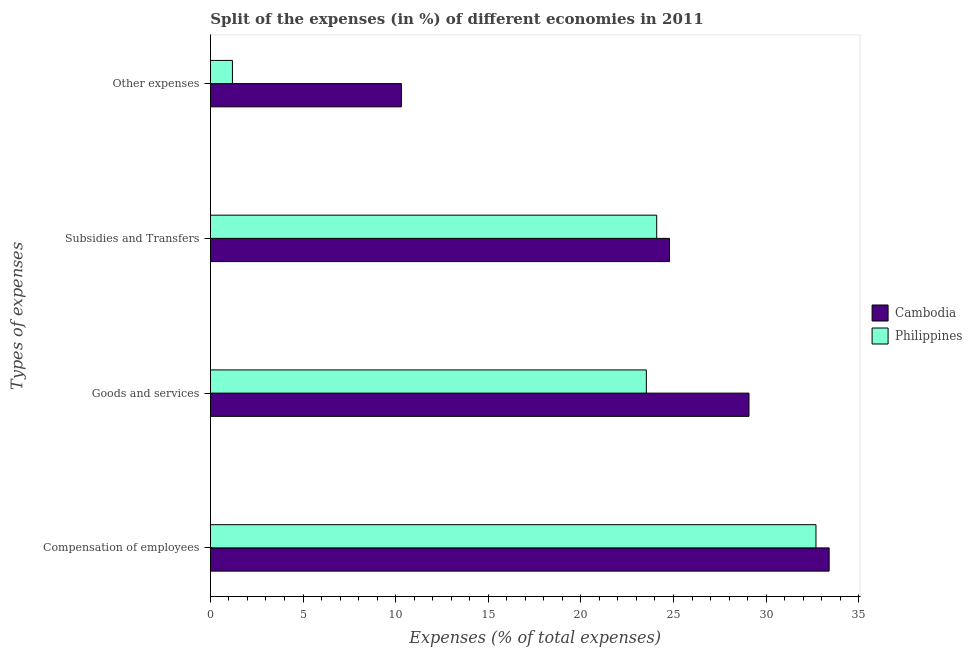How many different coloured bars are there?
Make the answer very short. 2. How many bars are there on the 2nd tick from the top?
Your answer should be compact. 2. What is the label of the 4th group of bars from the top?
Give a very brief answer. Compensation of employees. What is the percentage of amount spent on compensation of employees in Philippines?
Offer a terse response. 32.69. Across all countries, what is the maximum percentage of amount spent on compensation of employees?
Give a very brief answer. 33.4. Across all countries, what is the minimum percentage of amount spent on subsidies?
Make the answer very short. 24.09. In which country was the percentage of amount spent on other expenses maximum?
Offer a terse response. Cambodia. What is the total percentage of amount spent on goods and services in the graph?
Your answer should be very brief. 52.61. What is the difference between the percentage of amount spent on subsidies in Cambodia and that in Philippines?
Your response must be concise. 0.69. What is the difference between the percentage of amount spent on subsidies in Philippines and the percentage of amount spent on compensation of employees in Cambodia?
Your response must be concise. -9.31. What is the average percentage of amount spent on subsidies per country?
Your answer should be very brief. 24.44. What is the difference between the percentage of amount spent on goods and services and percentage of amount spent on other expenses in Cambodia?
Offer a terse response. 18.76. In how many countries, is the percentage of amount spent on compensation of employees greater than 27 %?
Offer a terse response. 2. What is the ratio of the percentage of amount spent on goods and services in Philippines to that in Cambodia?
Provide a short and direct response. 0.81. Is the difference between the percentage of amount spent on other expenses in Cambodia and Philippines greater than the difference between the percentage of amount spent on compensation of employees in Cambodia and Philippines?
Offer a terse response. Yes. What is the difference between the highest and the second highest percentage of amount spent on compensation of employees?
Keep it short and to the point. 0.71. What is the difference between the highest and the lowest percentage of amount spent on other expenses?
Keep it short and to the point. 9.12. In how many countries, is the percentage of amount spent on goods and services greater than the average percentage of amount spent on goods and services taken over all countries?
Keep it short and to the point. 1. Is the sum of the percentage of amount spent on compensation of employees in Cambodia and Philippines greater than the maximum percentage of amount spent on goods and services across all countries?
Provide a succinct answer. Yes. Is it the case that in every country, the sum of the percentage of amount spent on goods and services and percentage of amount spent on compensation of employees is greater than the sum of percentage of amount spent on subsidies and percentage of amount spent on other expenses?
Offer a terse response. No. What does the 2nd bar from the top in Goods and services represents?
Keep it short and to the point. Cambodia. What does the 1st bar from the bottom in Subsidies and Transfers represents?
Provide a short and direct response. Cambodia. Are all the bars in the graph horizontal?
Your answer should be compact. Yes. How many countries are there in the graph?
Make the answer very short. 2. Does the graph contain any zero values?
Your answer should be compact. No. Where does the legend appear in the graph?
Offer a terse response. Center right. How many legend labels are there?
Make the answer very short. 2. What is the title of the graph?
Offer a terse response. Split of the expenses (in %) of different economies in 2011. Does "Vanuatu" appear as one of the legend labels in the graph?
Offer a terse response. No. What is the label or title of the X-axis?
Ensure brevity in your answer.  Expenses (% of total expenses). What is the label or title of the Y-axis?
Provide a succinct answer. Types of expenses. What is the Expenses (% of total expenses) of Cambodia in Compensation of employees?
Ensure brevity in your answer.  33.4. What is the Expenses (% of total expenses) of Philippines in Compensation of employees?
Your answer should be compact. 32.69. What is the Expenses (% of total expenses) of Cambodia in Goods and services?
Provide a short and direct response. 29.08. What is the Expenses (% of total expenses) in Philippines in Goods and services?
Provide a succinct answer. 23.54. What is the Expenses (% of total expenses) of Cambodia in Subsidies and Transfers?
Make the answer very short. 24.79. What is the Expenses (% of total expenses) of Philippines in Subsidies and Transfers?
Offer a terse response. 24.09. What is the Expenses (% of total expenses) in Cambodia in Other expenses?
Offer a very short reply. 10.31. What is the Expenses (% of total expenses) of Philippines in Other expenses?
Offer a very short reply. 1.19. Across all Types of expenses, what is the maximum Expenses (% of total expenses) of Cambodia?
Your response must be concise. 33.4. Across all Types of expenses, what is the maximum Expenses (% of total expenses) of Philippines?
Offer a terse response. 32.69. Across all Types of expenses, what is the minimum Expenses (% of total expenses) of Cambodia?
Provide a succinct answer. 10.31. Across all Types of expenses, what is the minimum Expenses (% of total expenses) of Philippines?
Offer a very short reply. 1.19. What is the total Expenses (% of total expenses) of Cambodia in the graph?
Offer a terse response. 97.58. What is the total Expenses (% of total expenses) of Philippines in the graph?
Keep it short and to the point. 81.51. What is the difference between the Expenses (% of total expenses) of Cambodia in Compensation of employees and that in Goods and services?
Give a very brief answer. 4.33. What is the difference between the Expenses (% of total expenses) of Philippines in Compensation of employees and that in Goods and services?
Give a very brief answer. 9.16. What is the difference between the Expenses (% of total expenses) in Cambodia in Compensation of employees and that in Subsidies and Transfers?
Offer a very short reply. 8.62. What is the difference between the Expenses (% of total expenses) in Philippines in Compensation of employees and that in Subsidies and Transfers?
Provide a short and direct response. 8.6. What is the difference between the Expenses (% of total expenses) in Cambodia in Compensation of employees and that in Other expenses?
Provide a succinct answer. 23.09. What is the difference between the Expenses (% of total expenses) of Philippines in Compensation of employees and that in Other expenses?
Ensure brevity in your answer.  31.5. What is the difference between the Expenses (% of total expenses) in Cambodia in Goods and services and that in Subsidies and Transfers?
Provide a succinct answer. 4.29. What is the difference between the Expenses (% of total expenses) of Philippines in Goods and services and that in Subsidies and Transfers?
Offer a terse response. -0.56. What is the difference between the Expenses (% of total expenses) of Cambodia in Goods and services and that in Other expenses?
Keep it short and to the point. 18.76. What is the difference between the Expenses (% of total expenses) in Philippines in Goods and services and that in Other expenses?
Ensure brevity in your answer.  22.34. What is the difference between the Expenses (% of total expenses) of Cambodia in Subsidies and Transfers and that in Other expenses?
Offer a very short reply. 14.47. What is the difference between the Expenses (% of total expenses) in Philippines in Subsidies and Transfers and that in Other expenses?
Make the answer very short. 22.9. What is the difference between the Expenses (% of total expenses) of Cambodia in Compensation of employees and the Expenses (% of total expenses) of Philippines in Goods and services?
Offer a terse response. 9.87. What is the difference between the Expenses (% of total expenses) in Cambodia in Compensation of employees and the Expenses (% of total expenses) in Philippines in Subsidies and Transfers?
Your response must be concise. 9.31. What is the difference between the Expenses (% of total expenses) in Cambodia in Compensation of employees and the Expenses (% of total expenses) in Philippines in Other expenses?
Your answer should be very brief. 32.21. What is the difference between the Expenses (% of total expenses) of Cambodia in Goods and services and the Expenses (% of total expenses) of Philippines in Subsidies and Transfers?
Your response must be concise. 4.98. What is the difference between the Expenses (% of total expenses) in Cambodia in Goods and services and the Expenses (% of total expenses) in Philippines in Other expenses?
Keep it short and to the point. 27.89. What is the difference between the Expenses (% of total expenses) in Cambodia in Subsidies and Transfers and the Expenses (% of total expenses) in Philippines in Other expenses?
Make the answer very short. 23.6. What is the average Expenses (% of total expenses) of Cambodia per Types of expenses?
Provide a succinct answer. 24.4. What is the average Expenses (% of total expenses) of Philippines per Types of expenses?
Your answer should be very brief. 20.38. What is the difference between the Expenses (% of total expenses) of Cambodia and Expenses (% of total expenses) of Philippines in Compensation of employees?
Make the answer very short. 0.71. What is the difference between the Expenses (% of total expenses) in Cambodia and Expenses (% of total expenses) in Philippines in Goods and services?
Provide a succinct answer. 5.54. What is the difference between the Expenses (% of total expenses) of Cambodia and Expenses (% of total expenses) of Philippines in Subsidies and Transfers?
Your response must be concise. 0.69. What is the difference between the Expenses (% of total expenses) of Cambodia and Expenses (% of total expenses) of Philippines in Other expenses?
Offer a terse response. 9.12. What is the ratio of the Expenses (% of total expenses) of Cambodia in Compensation of employees to that in Goods and services?
Ensure brevity in your answer.  1.15. What is the ratio of the Expenses (% of total expenses) of Philippines in Compensation of employees to that in Goods and services?
Your response must be concise. 1.39. What is the ratio of the Expenses (% of total expenses) in Cambodia in Compensation of employees to that in Subsidies and Transfers?
Give a very brief answer. 1.35. What is the ratio of the Expenses (% of total expenses) in Philippines in Compensation of employees to that in Subsidies and Transfers?
Offer a terse response. 1.36. What is the ratio of the Expenses (% of total expenses) in Cambodia in Compensation of employees to that in Other expenses?
Give a very brief answer. 3.24. What is the ratio of the Expenses (% of total expenses) of Philippines in Compensation of employees to that in Other expenses?
Your answer should be very brief. 27.46. What is the ratio of the Expenses (% of total expenses) of Cambodia in Goods and services to that in Subsidies and Transfers?
Your answer should be very brief. 1.17. What is the ratio of the Expenses (% of total expenses) of Philippines in Goods and services to that in Subsidies and Transfers?
Your answer should be very brief. 0.98. What is the ratio of the Expenses (% of total expenses) of Cambodia in Goods and services to that in Other expenses?
Offer a very short reply. 2.82. What is the ratio of the Expenses (% of total expenses) in Philippines in Goods and services to that in Other expenses?
Your answer should be very brief. 19.77. What is the ratio of the Expenses (% of total expenses) in Cambodia in Subsidies and Transfers to that in Other expenses?
Your answer should be compact. 2.4. What is the ratio of the Expenses (% of total expenses) of Philippines in Subsidies and Transfers to that in Other expenses?
Ensure brevity in your answer.  20.24. What is the difference between the highest and the second highest Expenses (% of total expenses) in Cambodia?
Your answer should be very brief. 4.33. What is the difference between the highest and the second highest Expenses (% of total expenses) in Philippines?
Offer a terse response. 8.6. What is the difference between the highest and the lowest Expenses (% of total expenses) in Cambodia?
Give a very brief answer. 23.09. What is the difference between the highest and the lowest Expenses (% of total expenses) in Philippines?
Provide a short and direct response. 31.5. 